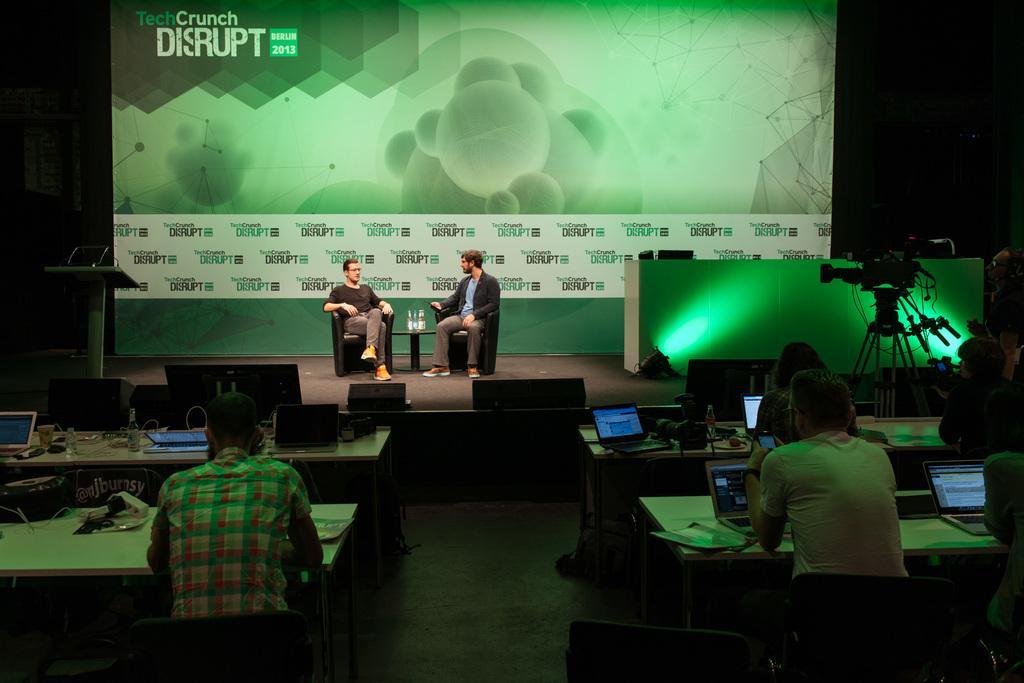How would you summarize this image in a sentence or two? In this picture we can see some people are sitting on chairs in front of desks, there are some laptops, bottles, wires and some papers present on theses desks, in the background there are two persons sitting on chairs in front of a table, there are bottles present on the table, on the left side there is a podium, on the right side we can see a camera, we can also see a hoarding in the background, there is some text present on the hoarding. 